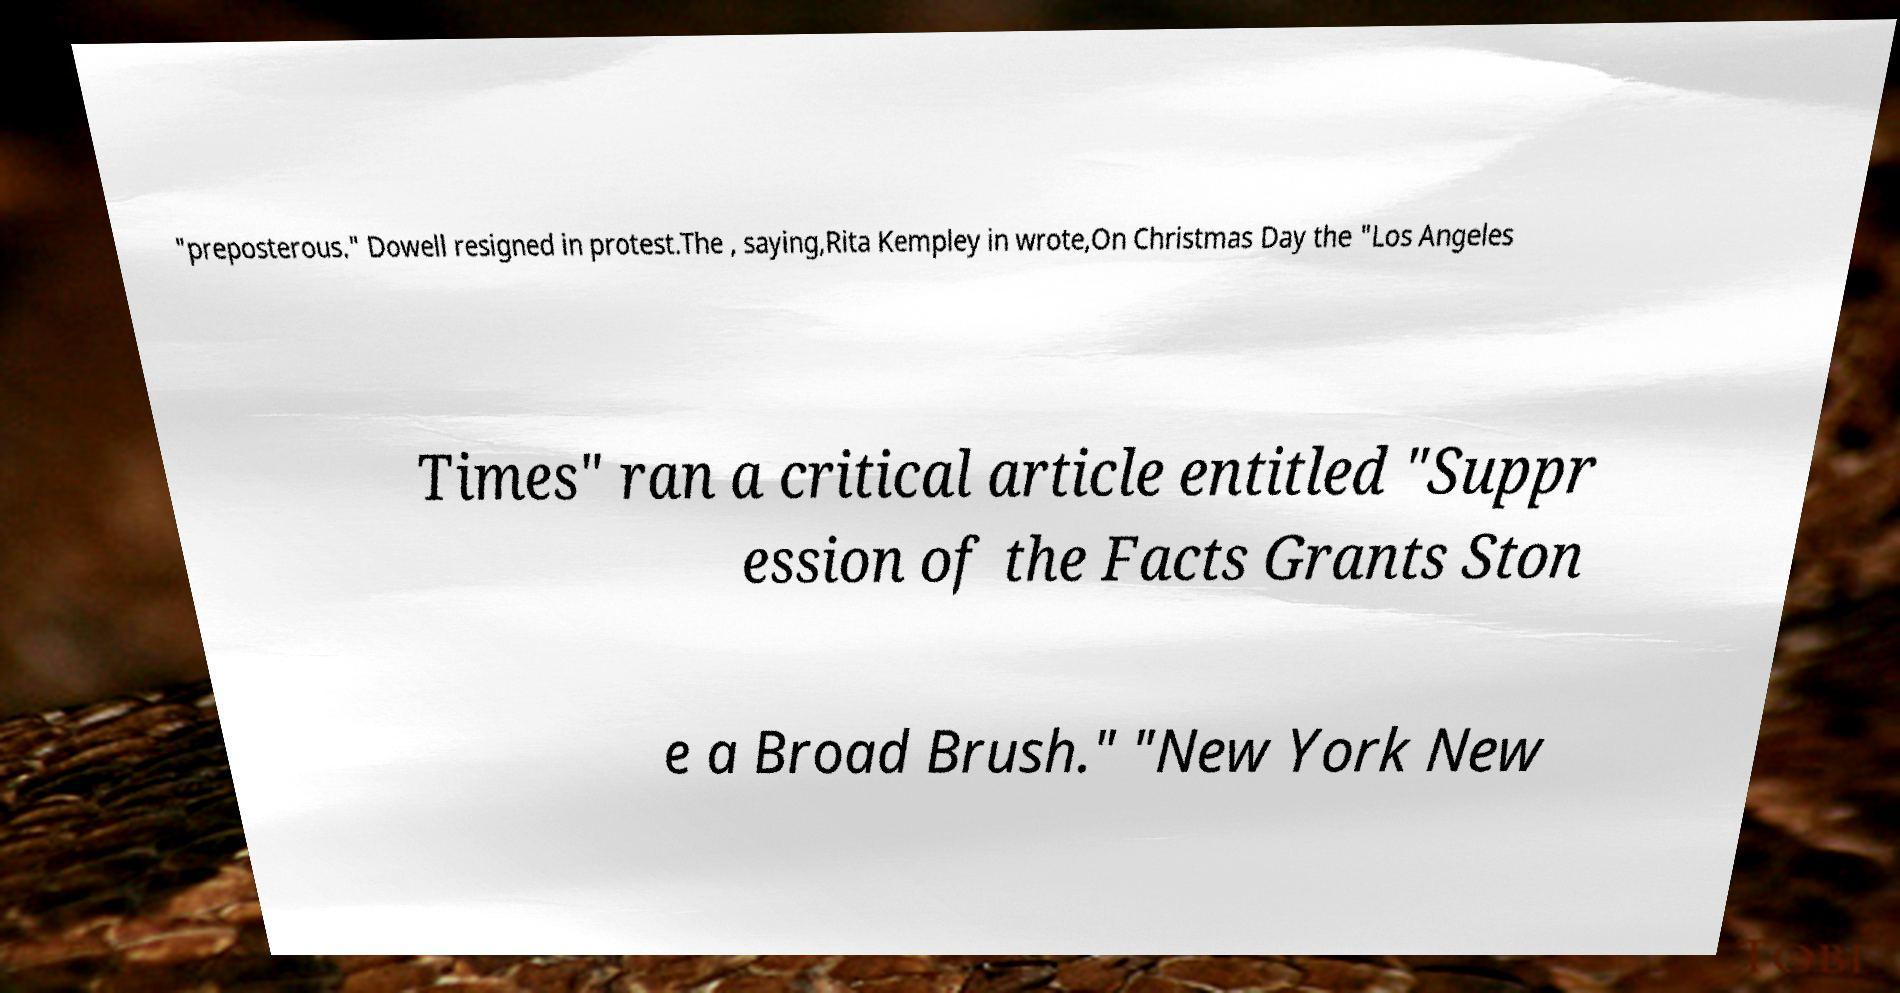Can you accurately transcribe the text from the provided image for me? "preposterous." Dowell resigned in protest.The , saying,Rita Kempley in wrote,On Christmas Day the "Los Angeles Times" ran a critical article entitled "Suppr ession of the Facts Grants Ston e a Broad Brush." "New York New 